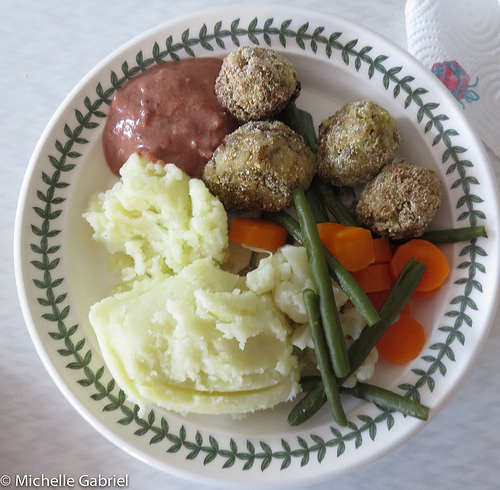<image>
Is there a gravy in the plate? Yes. The gravy is contained within or inside the plate, showing a containment relationship. 